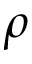Convert formula to latex. <formula><loc_0><loc_0><loc_500><loc_500>\rho</formula> 